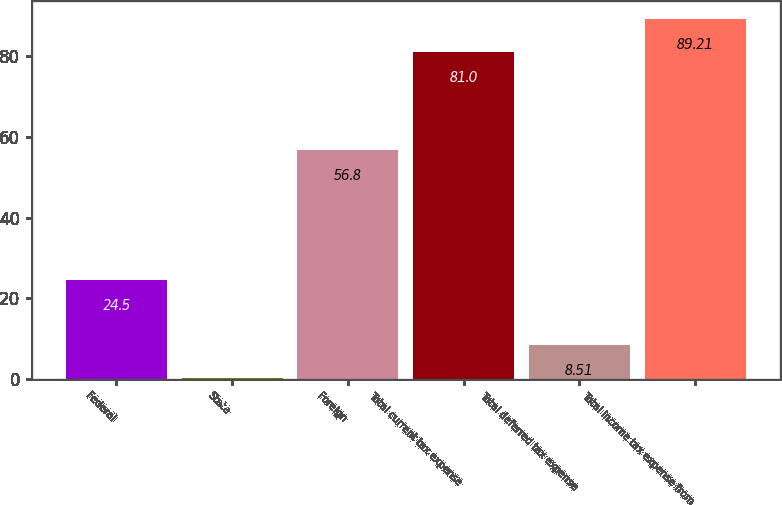Convert chart. <chart><loc_0><loc_0><loc_500><loc_500><bar_chart><fcel>Federal<fcel>State<fcel>Foreign<fcel>Total current tax expense<fcel>Total deferred tax expense<fcel>Total income tax expense from<nl><fcel>24.5<fcel>0.3<fcel>56.8<fcel>81<fcel>8.51<fcel>89.21<nl></chart> 